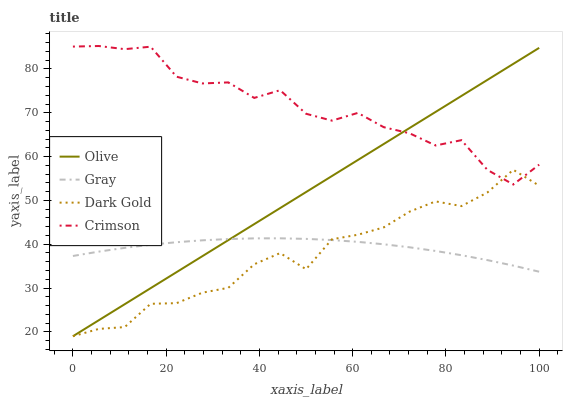Does Dark Gold have the minimum area under the curve?
Answer yes or no. Yes. Does Crimson have the maximum area under the curve?
Answer yes or no. Yes. Does Gray have the minimum area under the curve?
Answer yes or no. No. Does Gray have the maximum area under the curve?
Answer yes or no. No. Is Olive the smoothest?
Answer yes or no. Yes. Is Crimson the roughest?
Answer yes or no. Yes. Is Gray the smoothest?
Answer yes or no. No. Is Gray the roughest?
Answer yes or no. No. Does Olive have the lowest value?
Answer yes or no. Yes. Does Gray have the lowest value?
Answer yes or no. No. Does Crimson have the highest value?
Answer yes or no. Yes. Does Gray have the highest value?
Answer yes or no. No. Is Gray less than Crimson?
Answer yes or no. Yes. Is Crimson greater than Gray?
Answer yes or no. Yes. Does Crimson intersect Dark Gold?
Answer yes or no. Yes. Is Crimson less than Dark Gold?
Answer yes or no. No. Is Crimson greater than Dark Gold?
Answer yes or no. No. Does Gray intersect Crimson?
Answer yes or no. No. 